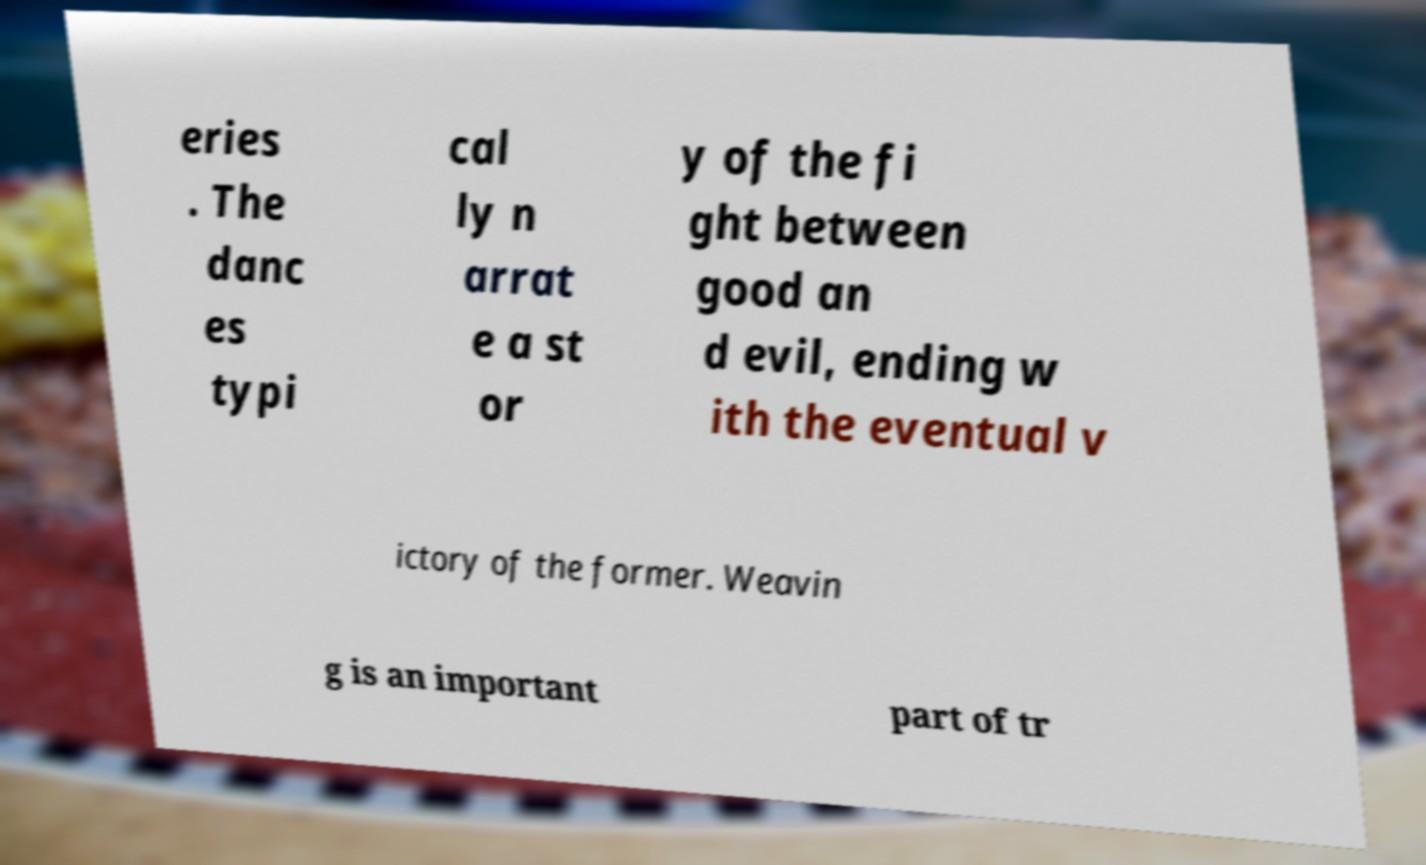What messages or text are displayed in this image? I need them in a readable, typed format. eries . The danc es typi cal ly n arrat e a st or y of the fi ght between good an d evil, ending w ith the eventual v ictory of the former. Weavin g is an important part of tr 